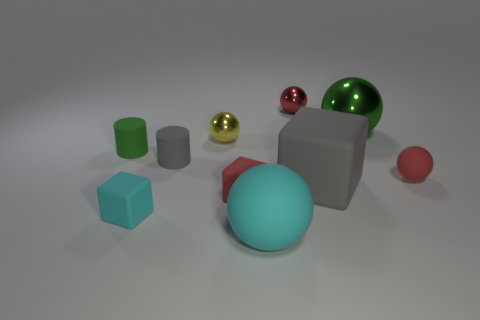What is the material of the other small sphere that is the same color as the tiny matte sphere?
Provide a succinct answer. Metal. There is a tiny shiny ball behind the green metal thing; does it have the same color as the small matte ball?
Your response must be concise. Yes. How many things are either red matte things that are on the right side of the big green thing or spheres?
Your response must be concise. 5. Are there more big things that are on the left side of the tiny red shiny object than red objects that are in front of the big metallic sphere?
Your answer should be compact. No. Does the tiny gray cylinder have the same material as the small yellow sphere?
Ensure brevity in your answer.  No. There is a matte object that is both on the right side of the small yellow metal thing and in front of the red rubber block; what shape is it?
Give a very brief answer. Sphere. What is the shape of the large object that is the same material as the big cube?
Offer a terse response. Sphere. Is there a big cyan shiny sphere?
Provide a short and direct response. No. There is a tiny red ball that is behind the big green metallic object; is there a large gray rubber cube that is left of it?
Provide a succinct answer. No. There is a green thing that is the same shape as the yellow object; what is it made of?
Ensure brevity in your answer.  Metal. 